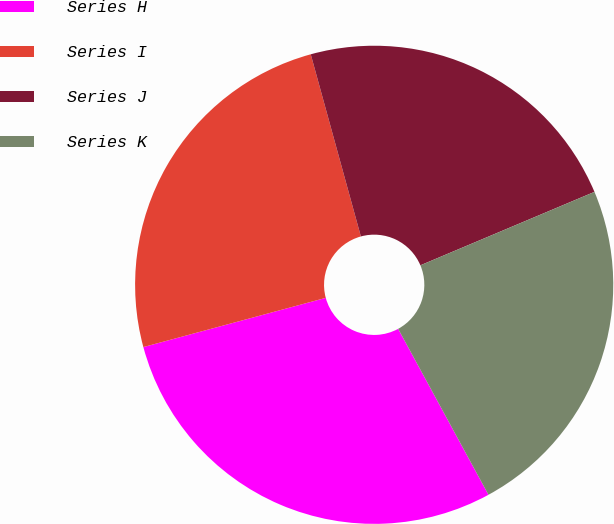<chart> <loc_0><loc_0><loc_500><loc_500><pie_chart><fcel>Series H<fcel>Series I<fcel>Series J<fcel>Series K<nl><fcel>28.74%<fcel>24.92%<fcel>22.92%<fcel>23.42%<nl></chart> 